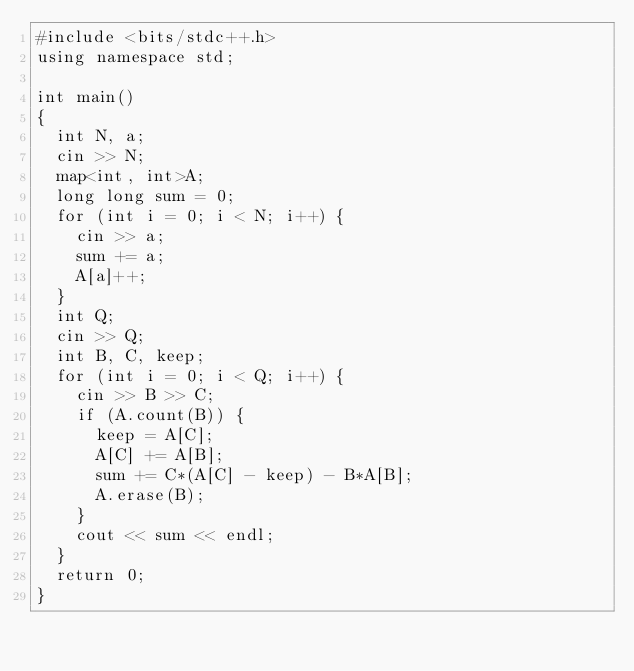<code> <loc_0><loc_0><loc_500><loc_500><_C++_>#include <bits/stdc++.h>
using namespace std;

int main()
{
  int N, a;
  cin >> N;
  map<int, int>A;
  long long sum = 0;
  for (int i = 0; i < N; i++) {
    cin >> a;
    sum += a;
    A[a]++;
  }
  int Q;
  cin >> Q;
  int B, C, keep;
  for (int i = 0; i < Q; i++) {
    cin >> B >> C;
    if (A.count(B)) {
      keep = A[C];
      A[C] += A[B];
      sum += C*(A[C] - keep) - B*A[B];
      A.erase(B);
    }
    cout << sum << endl;
  }
  return 0;
}</code> 